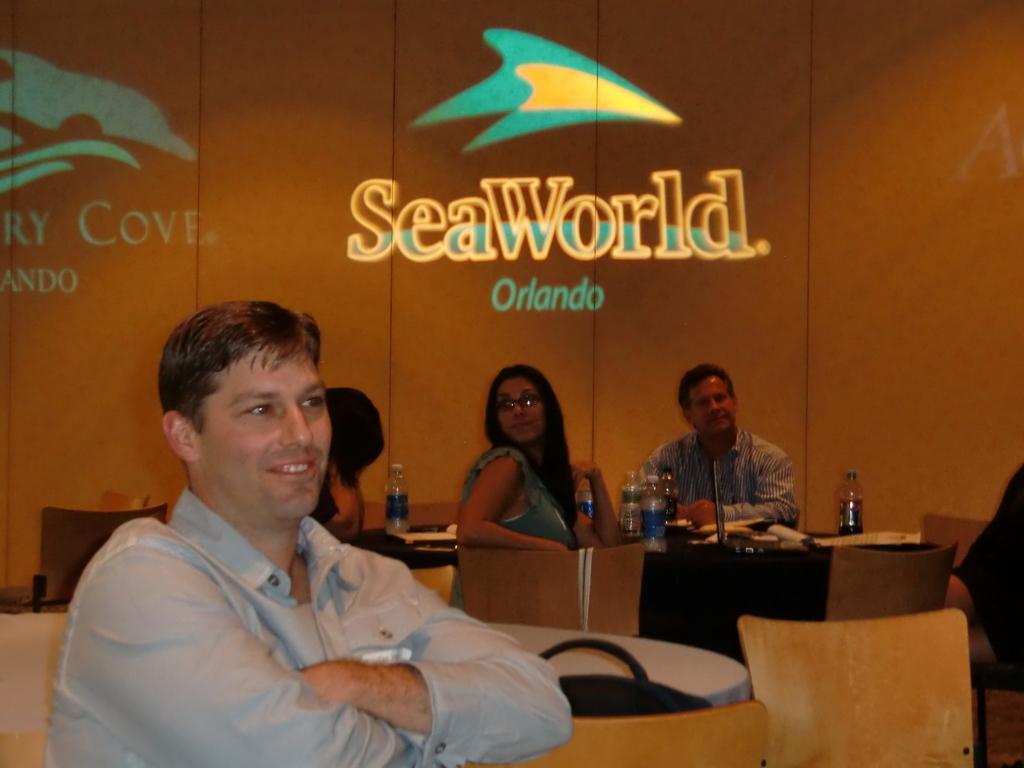Could you give a brief overview of what you see in this image? In this image i can see a person wearing a shirt is sitting on a chair and smiling. In the background i can see the wall and few persons sitting on chairs around the table, On the table i can see few bottles and few other objects. 